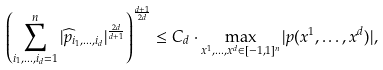Convert formula to latex. <formula><loc_0><loc_0><loc_500><loc_500>\left ( \sum _ { i _ { 1 } , \dots , i _ { d } = 1 } ^ { n } | \widehat { p } _ { i _ { 1 } , \dots , i _ { d } } | ^ { \frac { 2 d } { d + 1 } } \right ) ^ { \frac { d + 1 } { 2 d } } \leq C _ { d } \cdot \max _ { x ^ { 1 } , \dots , x ^ { d } \in [ - 1 , 1 ] ^ { n } } | p ( x ^ { 1 } , \dots , x ^ { d } ) | ,</formula> 